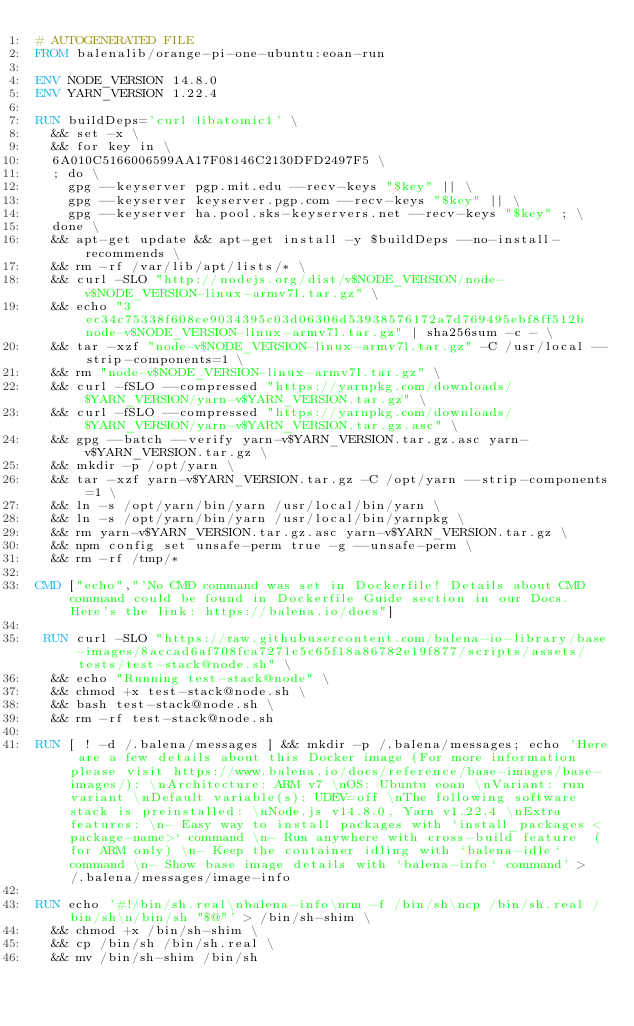<code> <loc_0><loc_0><loc_500><loc_500><_Dockerfile_># AUTOGENERATED FILE
FROM balenalib/orange-pi-one-ubuntu:eoan-run

ENV NODE_VERSION 14.8.0
ENV YARN_VERSION 1.22.4

RUN buildDeps='curl libatomic1' \
	&& set -x \
	&& for key in \
	6A010C5166006599AA17F08146C2130DFD2497F5 \
	; do \
		gpg --keyserver pgp.mit.edu --recv-keys "$key" || \
		gpg --keyserver keyserver.pgp.com --recv-keys "$key" || \
		gpg --keyserver ha.pool.sks-keyservers.net --recv-keys "$key" ; \
	done \
	&& apt-get update && apt-get install -y $buildDeps --no-install-recommends \
	&& rm -rf /var/lib/apt/lists/* \
	&& curl -SLO "http://nodejs.org/dist/v$NODE_VERSION/node-v$NODE_VERSION-linux-armv7l.tar.gz" \
	&& echo "3ec34c75338f608ce9034395c03d06306d53938576172a7d769495ebf8ff512b  node-v$NODE_VERSION-linux-armv7l.tar.gz" | sha256sum -c - \
	&& tar -xzf "node-v$NODE_VERSION-linux-armv7l.tar.gz" -C /usr/local --strip-components=1 \
	&& rm "node-v$NODE_VERSION-linux-armv7l.tar.gz" \
	&& curl -fSLO --compressed "https://yarnpkg.com/downloads/$YARN_VERSION/yarn-v$YARN_VERSION.tar.gz" \
	&& curl -fSLO --compressed "https://yarnpkg.com/downloads/$YARN_VERSION/yarn-v$YARN_VERSION.tar.gz.asc" \
	&& gpg --batch --verify yarn-v$YARN_VERSION.tar.gz.asc yarn-v$YARN_VERSION.tar.gz \
	&& mkdir -p /opt/yarn \
	&& tar -xzf yarn-v$YARN_VERSION.tar.gz -C /opt/yarn --strip-components=1 \
	&& ln -s /opt/yarn/bin/yarn /usr/local/bin/yarn \
	&& ln -s /opt/yarn/bin/yarn /usr/local/bin/yarnpkg \
	&& rm yarn-v$YARN_VERSION.tar.gz.asc yarn-v$YARN_VERSION.tar.gz \
	&& npm config set unsafe-perm true -g --unsafe-perm \
	&& rm -rf /tmp/*

CMD ["echo","'No CMD command was set in Dockerfile! Details about CMD command could be found in Dockerfile Guide section in our Docs. Here's the link: https://balena.io/docs"]

 RUN curl -SLO "https://raw.githubusercontent.com/balena-io-library/base-images/8accad6af708fca7271c5c65f18a86782e19f877/scripts/assets/tests/test-stack@node.sh" \
  && echo "Running test-stack@node" \
  && chmod +x test-stack@node.sh \
  && bash test-stack@node.sh \
  && rm -rf test-stack@node.sh 

RUN [ ! -d /.balena/messages ] && mkdir -p /.balena/messages; echo 'Here are a few details about this Docker image (For more information please visit https://www.balena.io/docs/reference/base-images/base-images/): \nArchitecture: ARM v7 \nOS: Ubuntu eoan \nVariant: run variant \nDefault variable(s): UDEV=off \nThe following software stack is preinstalled: \nNode.js v14.8.0, Yarn v1.22.4 \nExtra features: \n- Easy way to install packages with `install_packages <package-name>` command \n- Run anywhere with cross-build feature  (for ARM only) \n- Keep the container idling with `balena-idle` command \n- Show base image details with `balena-info` command' > /.balena/messages/image-info

RUN echo '#!/bin/sh.real\nbalena-info\nrm -f /bin/sh\ncp /bin/sh.real /bin/sh\n/bin/sh "$@"' > /bin/sh-shim \
	&& chmod +x /bin/sh-shim \
	&& cp /bin/sh /bin/sh.real \
	&& mv /bin/sh-shim /bin/sh</code> 